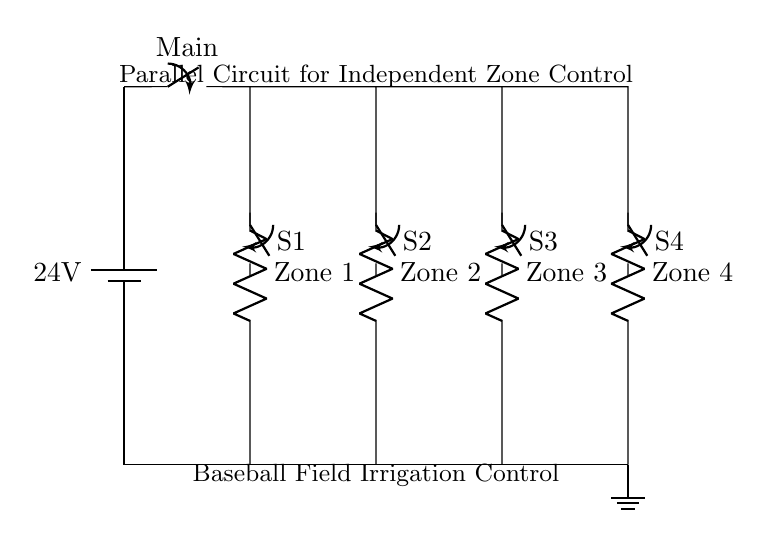What is the voltage of the power supply? The voltage of the power supply is indicated next to the battery symbol. It shows 24 volts, which is the potential difference provided by the battery in the circuit.
Answer: 24 volts How many zones of irrigation are controlled? The circuit diagram depicts four resistors, each labeled as a distinct zone for irrigation. Each of these zones corresponds to a separate branch of the parallel circuit. Therefore, there are four zones controlled.
Answer: Four What is the purpose of the individual switches? Each switch controls the flow of current to a specific zone. By opening or closing these switches, the operator can independently manage the irrigation for each zone without affecting the others. This arrangement allows flexible control of the irrigation system.
Answer: To control individual zones Is the circuit a series or parallel type? The circuit is a parallel type, as indicated by the layout where multiple branches (one for each zone) are connected alongside each other to the same voltage source. In a parallel circuit, each component operates independently, which is conducive for this application.
Answer: Parallel What happens if one zone's switch is turned off? If one zone's switch is turned off, the current will stop flowing to that zone, but the other zones will continue to receive power and water. This independent control characteristic is essential in irrigation systems to avoid overwatering or underwatering specific areas.
Answer: Only that zone stops Which component provides the control for the entire system? The main switch is the component that provides control for the entire irrigation system. It can disconnect the entire circuit from the power supply when turned off, making it a crucial part of the control system.
Answer: Main switch 